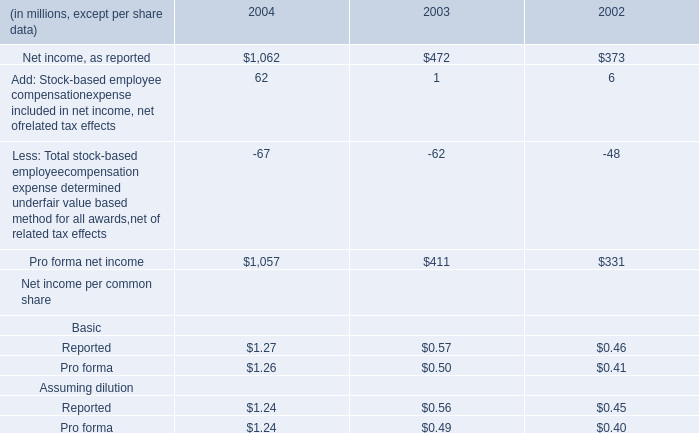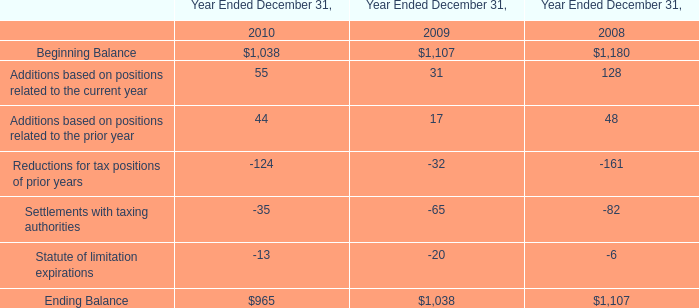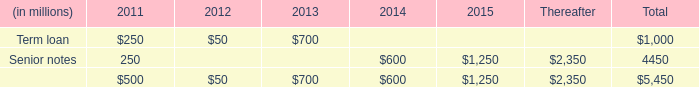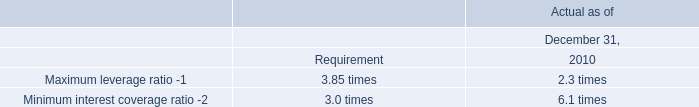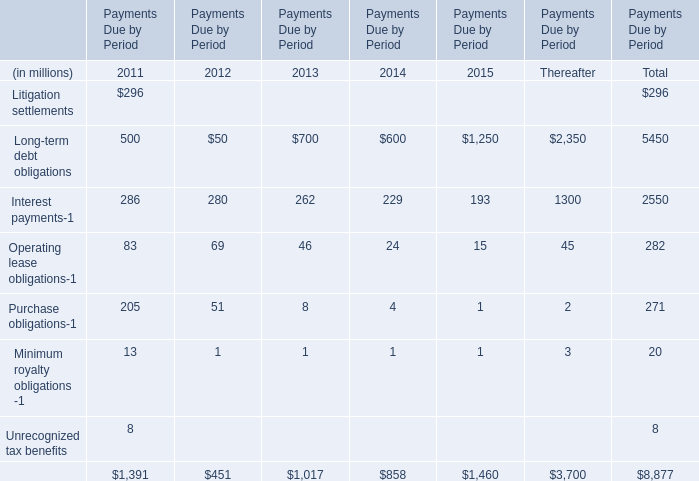What's the average of Beginning Balance of Year Ended December 31, 2010, and Net income, as reported of 2004 ? 
Computations: ((1038.0 + 1062.0) / 2)
Answer: 1050.0. 